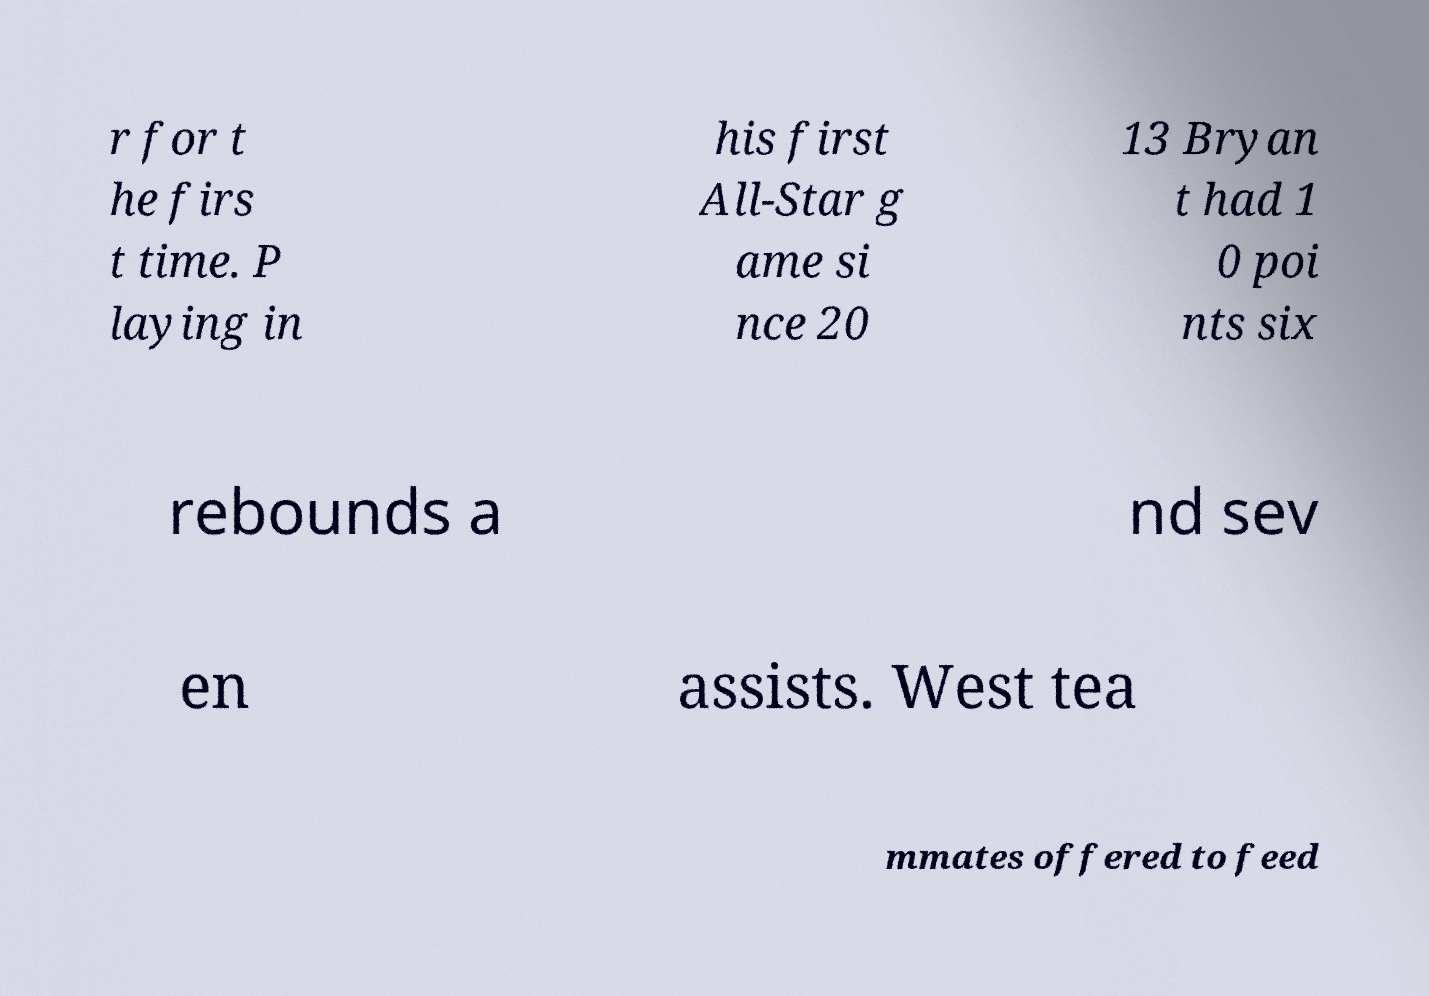Please read and relay the text visible in this image. What does it say? r for t he firs t time. P laying in his first All-Star g ame si nce 20 13 Bryan t had 1 0 poi nts six rebounds a nd sev en assists. West tea mmates offered to feed 